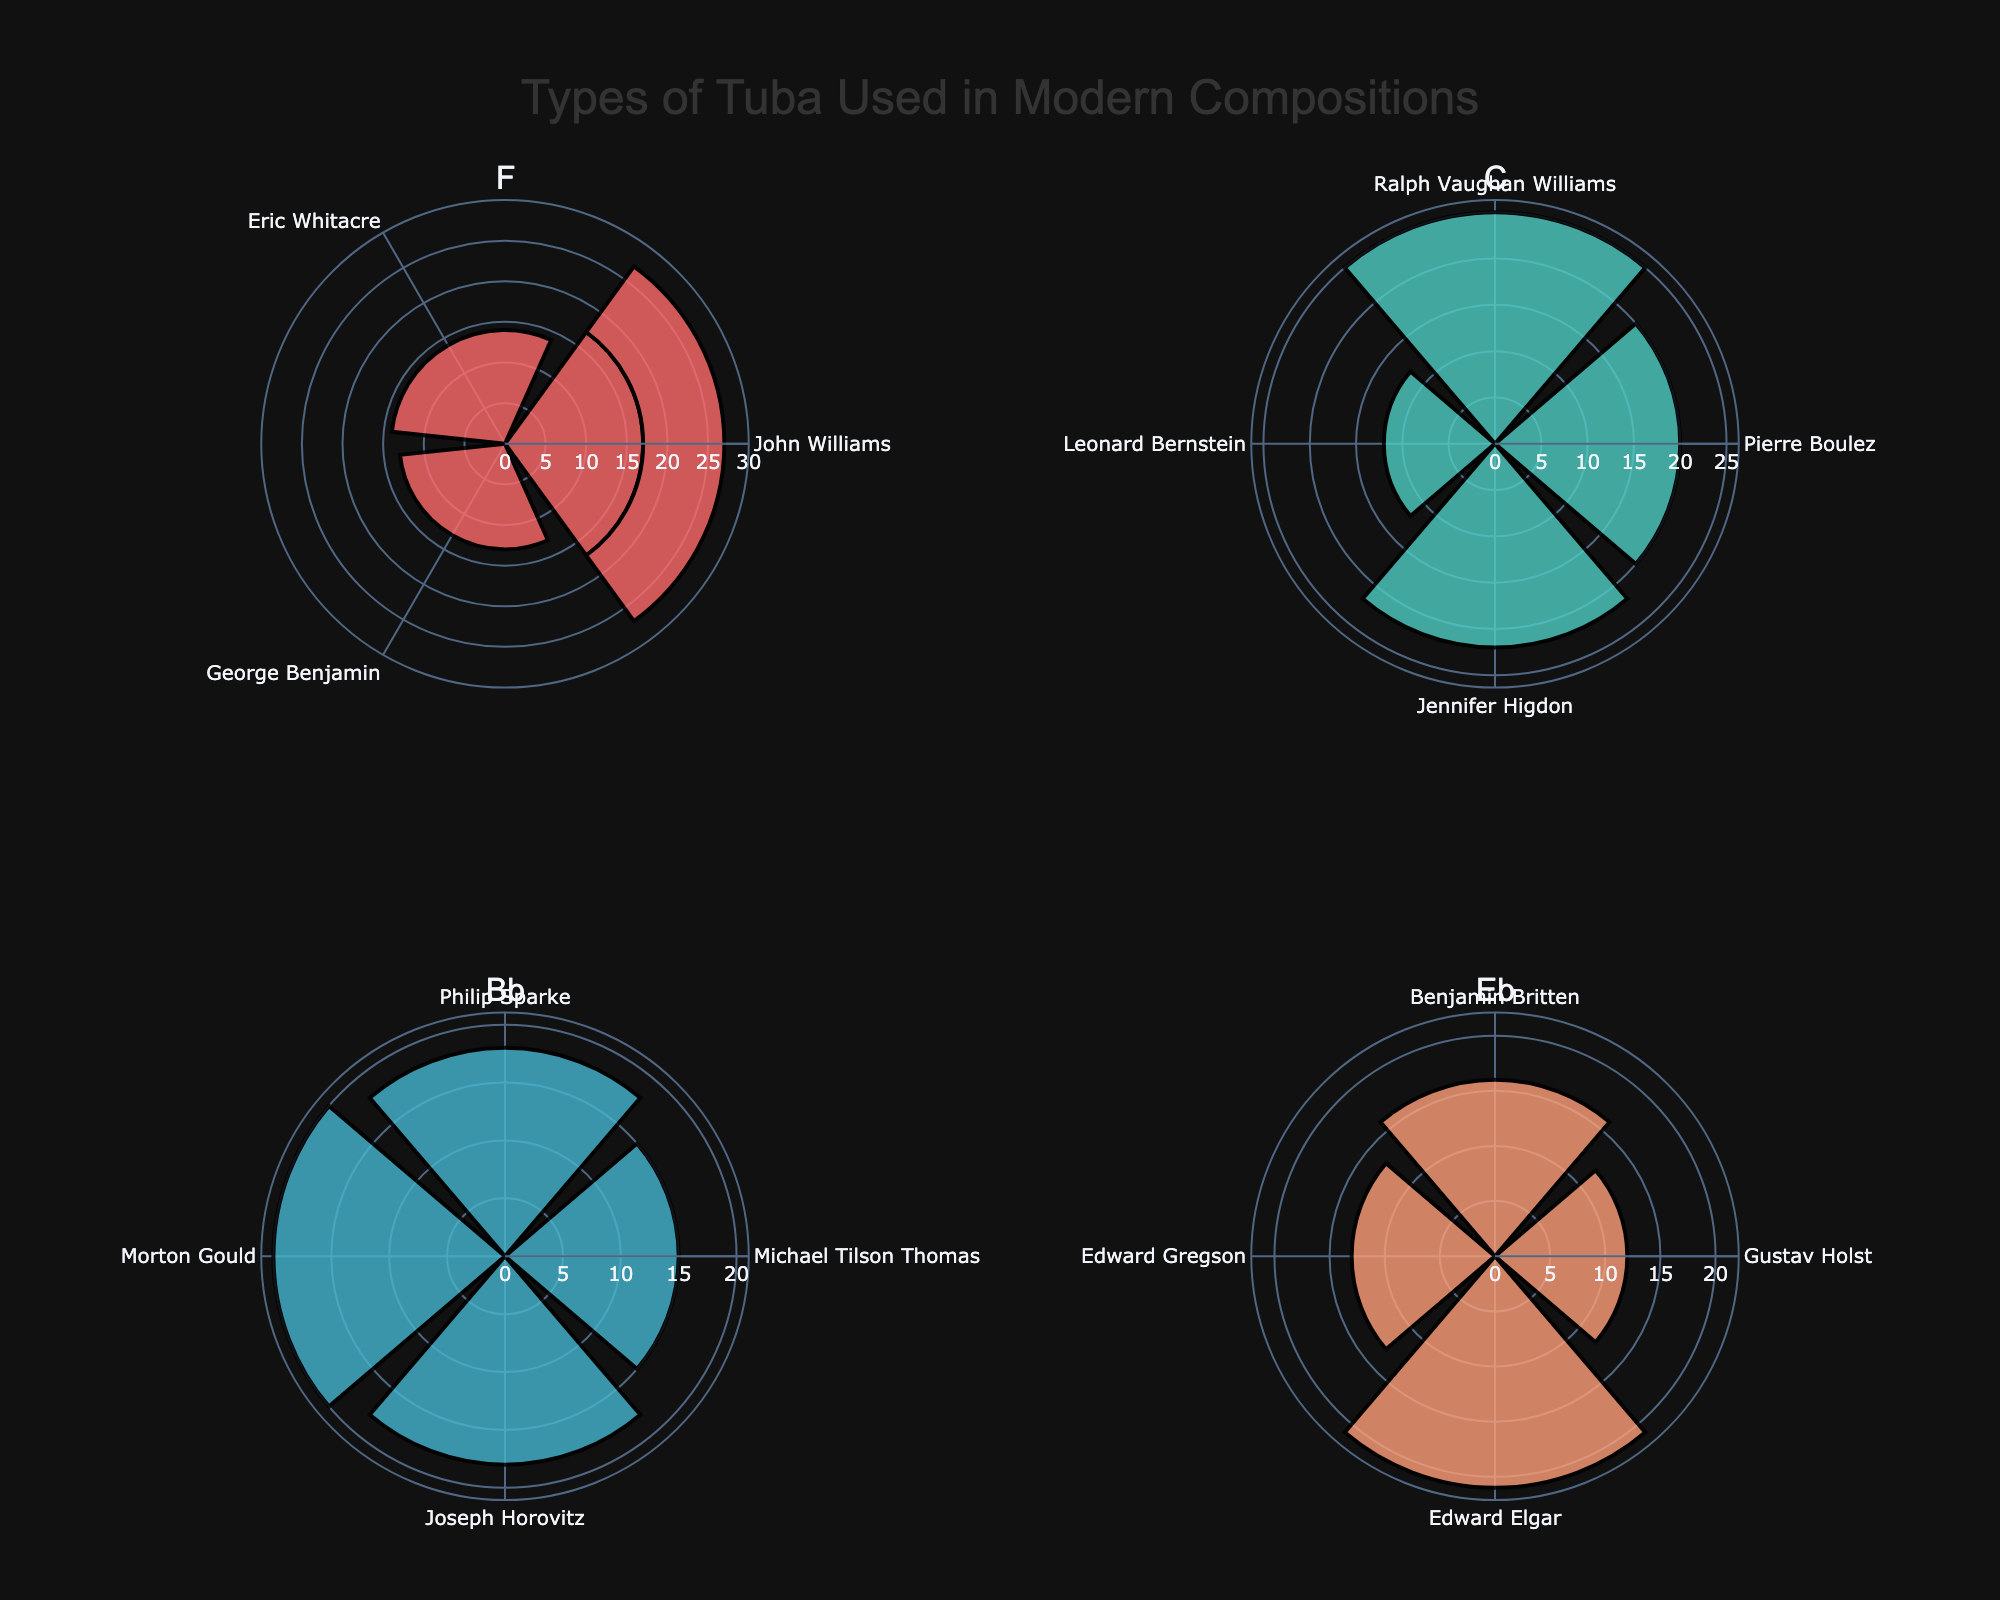what is the title of the figure? The title is located at the top of the figure and reads, "Types of Tuba Used in Modern Compositions".
Answer: Types of Tuba Used in Modern Compositions How many tubas of type F compositions are there? Count the sections or bars displaying "F" in the figure, indicated by their respective labels. There are four distinct compositions listed for tuba type F.
Answer: 4 Which tuba type has the highest occurrence in a single composition, and what is the occurrence count? Look for the longest radial bar in each subplot. The longest bar appears in the C tuba subplot for the "Concerto for Bass Tuba and Orchestra" by Ralph Vaughan Williams, which has an occurrence count of 25.
Answer: C, 25 Among the tubas used by John Williams, which tuba type and composition have the highest occurrences? In the subplot for tuba type F, examine the bars labeled by John Williams' compositions. The "Concerto for Tuba and Orchestra" has the highest occurrences with 17.
Answer: F, Concerto for Tuba and Orchestra What is the total occurrence count for tuba type Bb? Sum up the occurrences for all compositions in the Bb subplot: 15 (Street Song) + 18 (A Tuba Concerto) + 20 (Jericho Rhapsody) + 18 (Concerto for Euphonium) = 71.
Answer: 71 Which composer appears in more than one tuba type subplot and what are their occurrence counts? Check each subplot for repeated composer names. John Williams appears in tuba type F twice with 17 and 10 occurrences, respectively, and Michael Tilson Thomas appears in tuba type Bb with 15 occurrences.
Answer: John Williams (17, 10), Michael Tilson Thomas (15) Compare the total occurrences of compositions by Ralph Vaughan Williams and Philip Sparke. Which is higher? Ralph Vaughan Williams has one composition with 25 occurrences (Concerto for Bass Tuba and Orchestra), and Philip Sparke has one composition with 18 (A Tuba Concerto). Compare these numbers directly to see that Ralph Vaughan Williams has more occurrences.
Answer: Ralph Vaughan Williams How does the total number of occurrences for composers using C tubas compare to those using Eb tubas? Sum the occurrences for the C tubas: 20 (Pli selon pli) + 25 (Concerto for Bass Tuba and Orchestra) + 12 (Divertimento) + 22 (Low Brass Concerto) = 79.
Sum the occurrences for the Eb tubas: 12 (Planets Suite) + 16 (The Young Person's Guide to the Orchestra) + 13 (Tuba Concerto) + 21 (Pomp and Circumstance March No. 4) = 62.
Compare the totals: 79 (C) is greater than 62 (Eb).
Answer: C tubas (79) Are there any compositions with exactly 12 occurrences? If so, which ones? Observe the radial lengths and tick marks for values in the subplots. In the tuba type Eb subplot, "Planets Suite" and in the tuba type C subplot, "Divertimento" both have 12 occurrences.
Answer: Planets Suite, Divertimento 